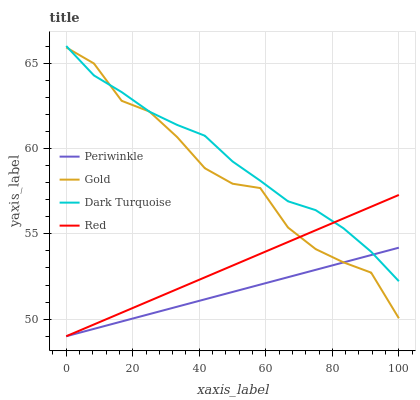Does Red have the minimum area under the curve?
Answer yes or no. No. Does Red have the maximum area under the curve?
Answer yes or no. No. Is Red the smoothest?
Answer yes or no. No. Is Red the roughest?
Answer yes or no. No. Does Gold have the lowest value?
Answer yes or no. No. Does Red have the highest value?
Answer yes or no. No. 